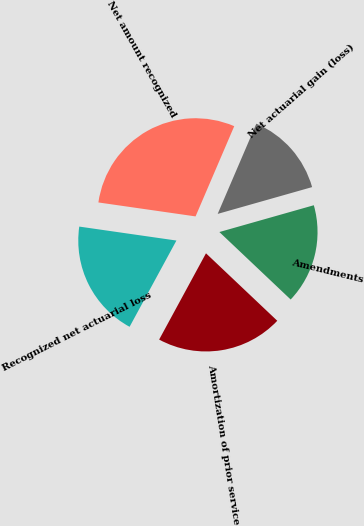Convert chart. <chart><loc_0><loc_0><loc_500><loc_500><pie_chart><fcel>Net actuarial gain (loss)<fcel>Amendments<fcel>Amortization of prior service<fcel>Recognized net actuarial loss<fcel>Net amount recognized<nl><fcel>14.15%<fcel>16.46%<fcel>20.85%<fcel>19.35%<fcel>29.17%<nl></chart> 